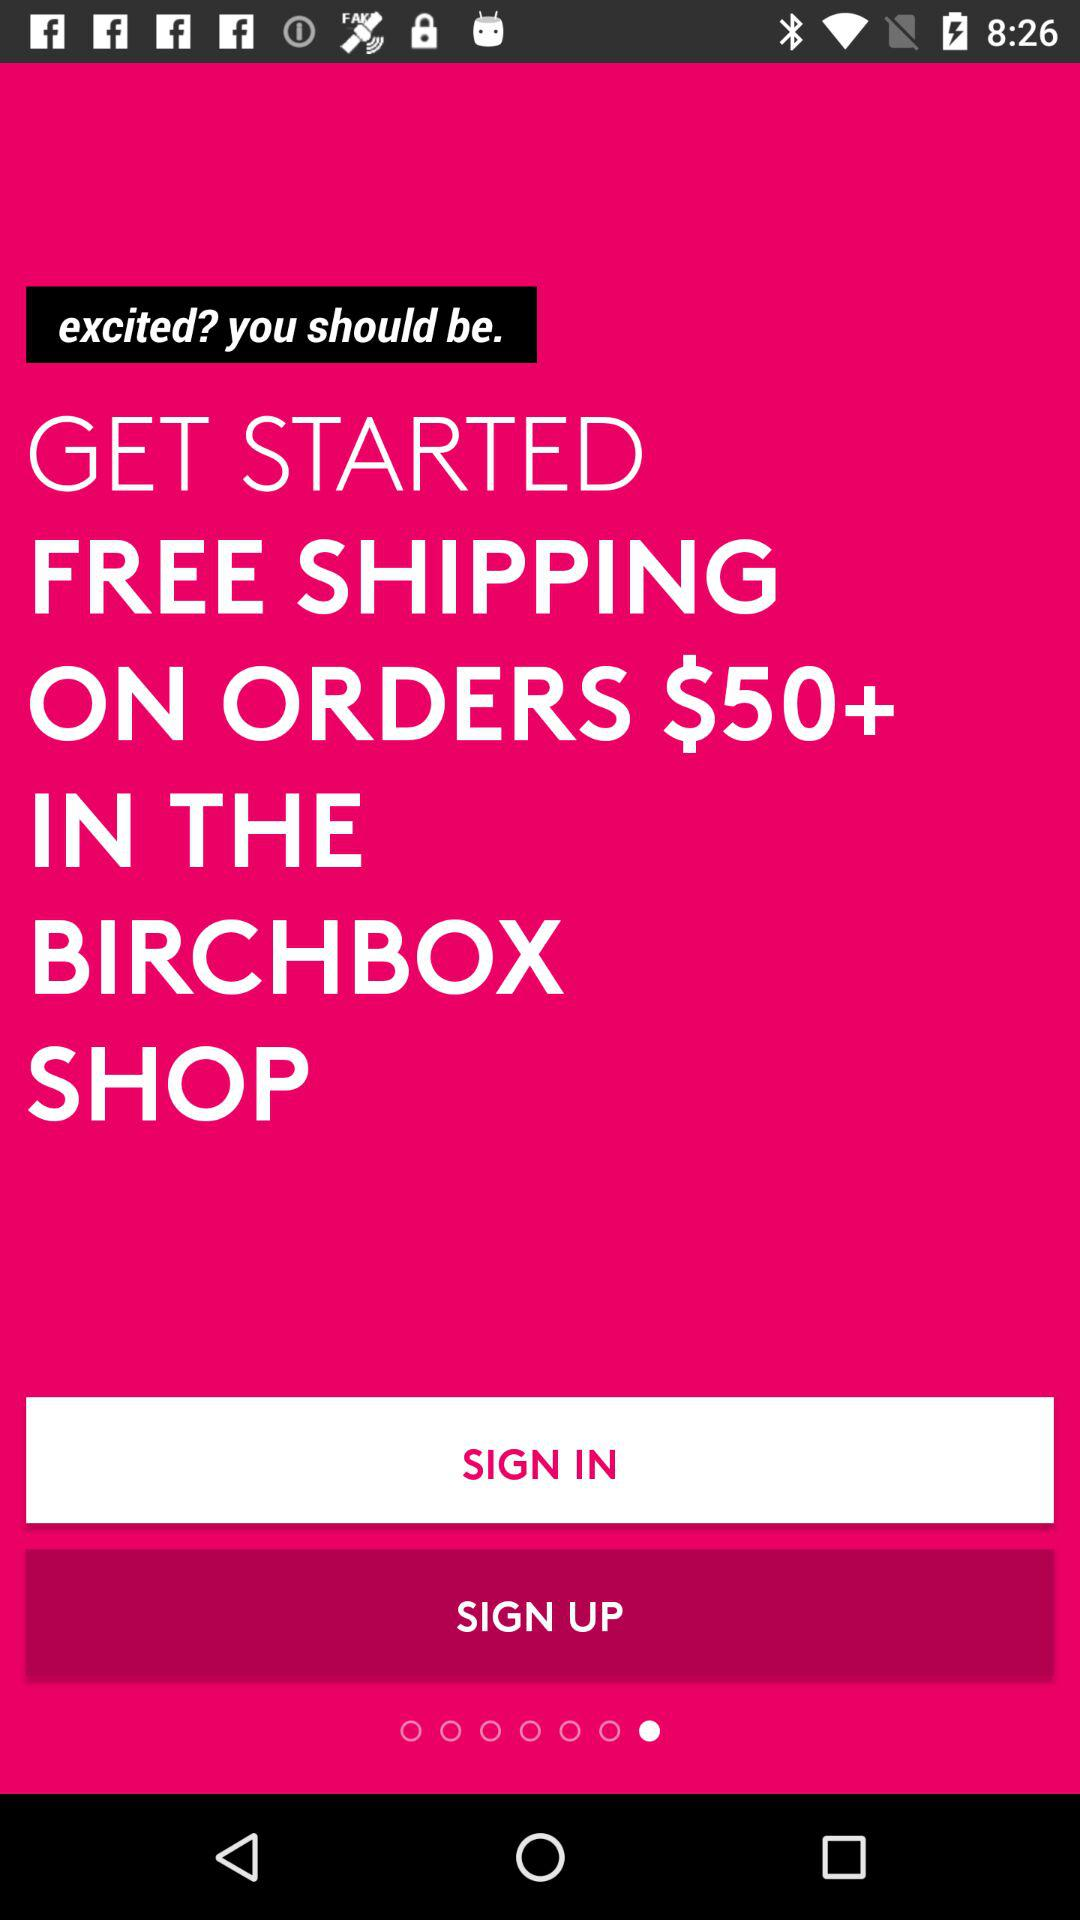What is the name of the application? The name of the application is "BIRCHBOX". 